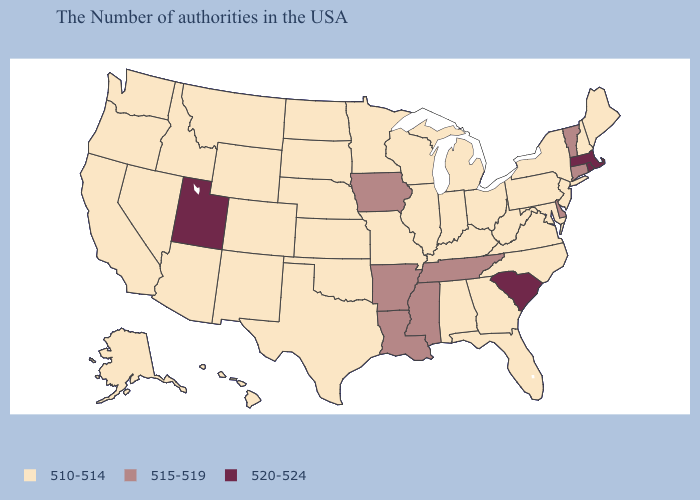What is the value of New York?
Short answer required. 510-514. Does Oklahoma have a higher value than Virginia?
Be succinct. No. What is the value of Ohio?
Write a very short answer. 510-514. Name the states that have a value in the range 515-519?
Quick response, please. Vermont, Connecticut, Delaware, Tennessee, Mississippi, Louisiana, Arkansas, Iowa. Is the legend a continuous bar?
Short answer required. No. Does North Dakota have the lowest value in the USA?
Give a very brief answer. Yes. What is the value of Wyoming?
Give a very brief answer. 510-514. Does North Dakota have a lower value than Massachusetts?
Keep it brief. Yes. What is the highest value in the USA?
Answer briefly. 520-524. Name the states that have a value in the range 515-519?
Concise answer only. Vermont, Connecticut, Delaware, Tennessee, Mississippi, Louisiana, Arkansas, Iowa. Name the states that have a value in the range 520-524?
Keep it brief. Massachusetts, Rhode Island, South Carolina, Utah. Does Nevada have the lowest value in the West?
Answer briefly. Yes. Name the states that have a value in the range 520-524?
Quick response, please. Massachusetts, Rhode Island, South Carolina, Utah. Does Montana have the lowest value in the West?
Concise answer only. Yes. Does Alaska have the same value as New York?
Short answer required. Yes. 